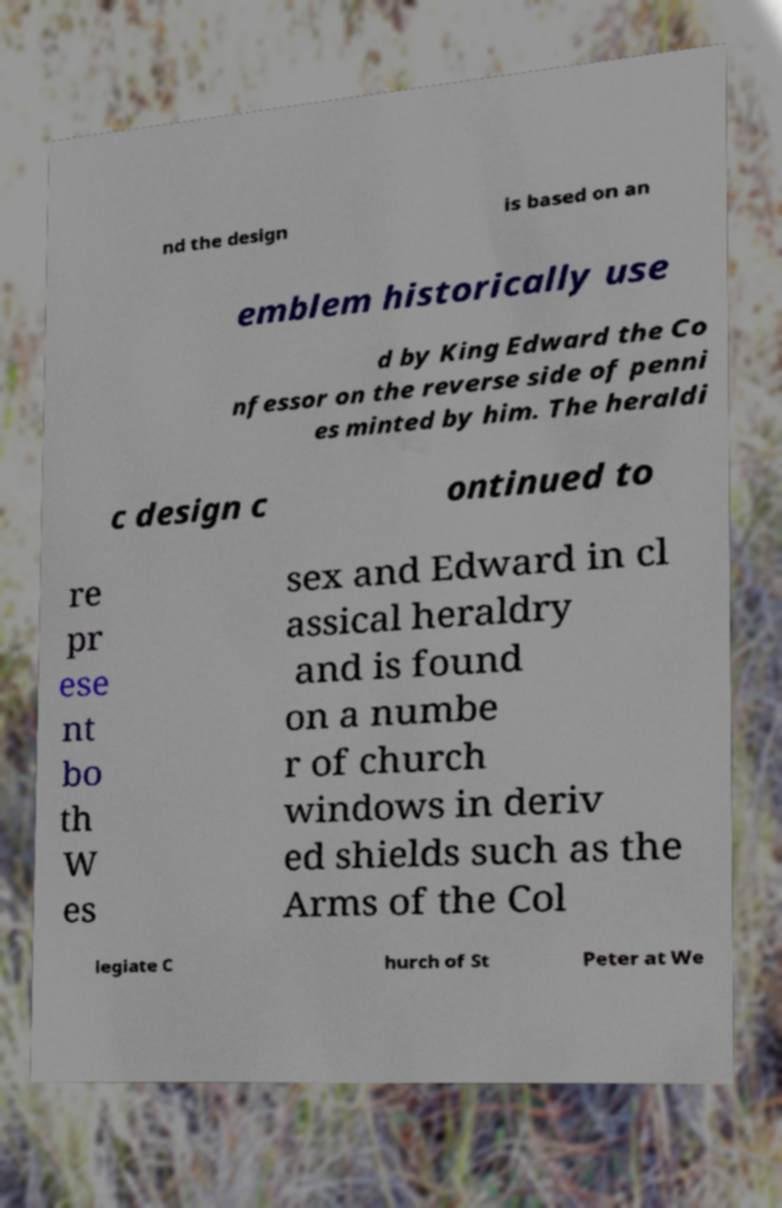Could you extract and type out the text from this image? nd the design is based on an emblem historically use d by King Edward the Co nfessor on the reverse side of penni es minted by him. The heraldi c design c ontinued to re pr ese nt bo th W es sex and Edward in cl assical heraldry and is found on a numbe r of church windows in deriv ed shields such as the Arms of the Col legiate C hurch of St Peter at We 